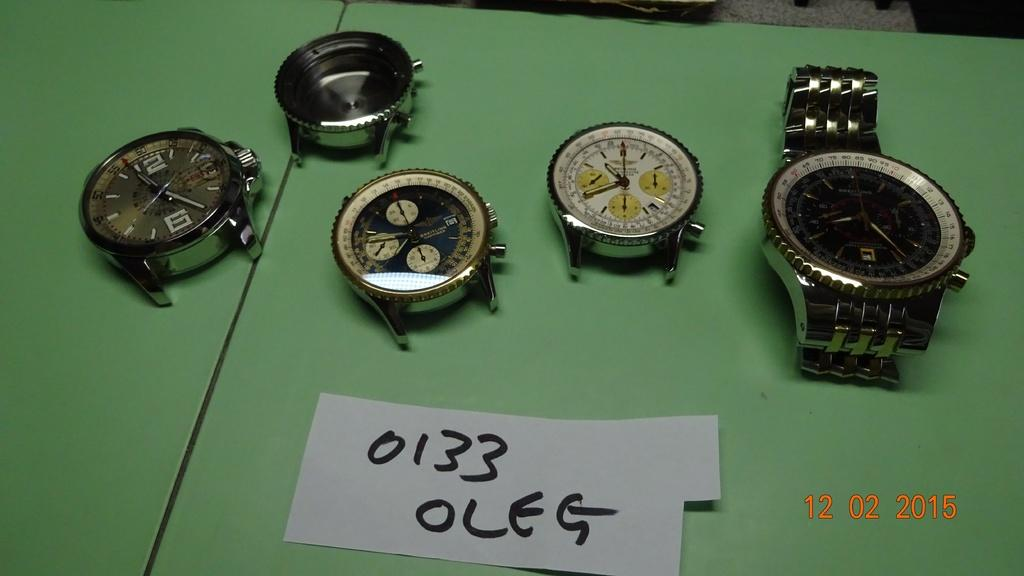<image>
Offer a succinct explanation of the picture presented. Watch faces are displayed against a green background with a handwritten sign that says 0133 Oleg. 